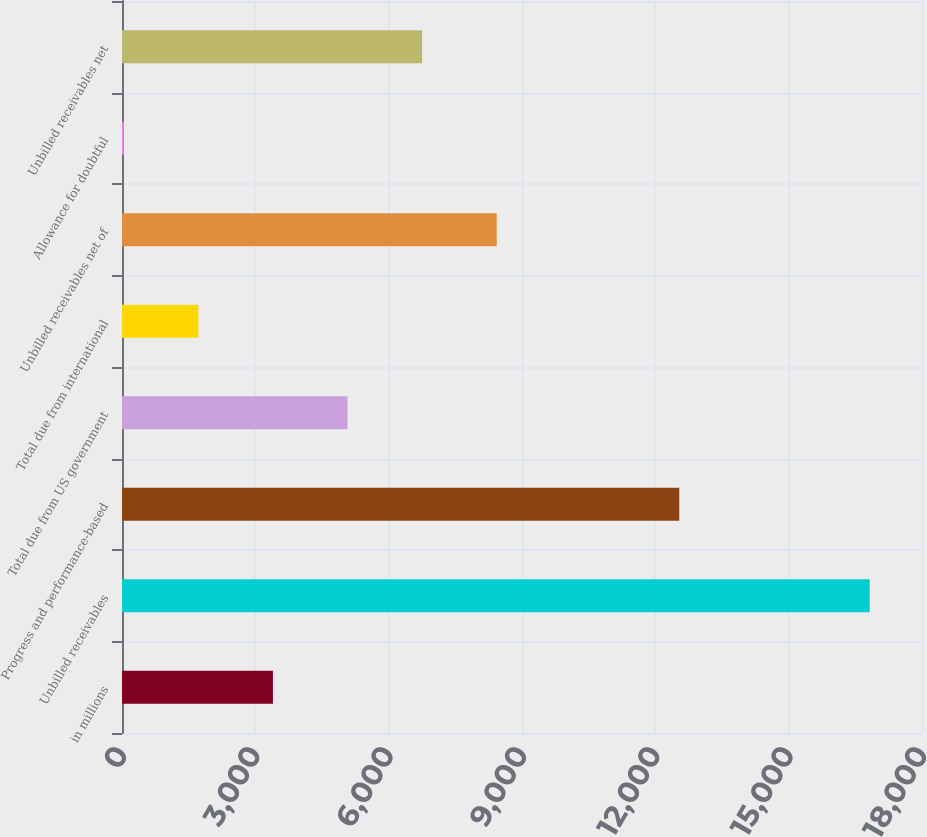Convert chart to OTSL. <chart><loc_0><loc_0><loc_500><loc_500><bar_chart><fcel>in millions<fcel>Unbilled receivables<fcel>Progress and performance-based<fcel>Total due from US government<fcel>Total due from international<fcel>Unbilled receivables net of<fcel>Allowance for doubtful<fcel>Unbilled receivables net<nl><fcel>3395.8<fcel>16823<fcel>12539<fcel>5074.2<fcel>1717.4<fcel>8431<fcel>39<fcel>6752.6<nl></chart> 